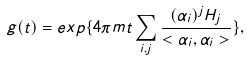Convert formula to latex. <formula><loc_0><loc_0><loc_500><loc_500>g ( t ) = e x p \{ 4 \pi m t \sum _ { i , j } \frac { ( \alpha _ { i } ) ^ { j } H _ { j } } { < \alpha _ { i } , \alpha _ { i } > } \} ,</formula> 